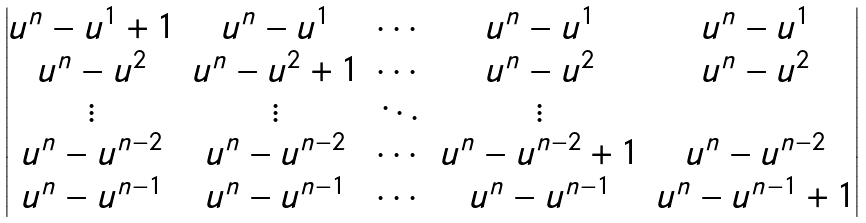Convert formula to latex. <formula><loc_0><loc_0><loc_500><loc_500>\begin{vmatrix} u ^ { n } - u ^ { 1 } + 1 & u ^ { n } - u ^ { 1 } & \cdots & u ^ { n } - u ^ { 1 } & u ^ { n } - u ^ { 1 } \\ u ^ { n } - u ^ { 2 } & u ^ { n } - u ^ { 2 } + 1 & \cdots & u ^ { n } - u ^ { 2 } & u ^ { n } - u ^ { 2 } \\ \vdots & \vdots & \ddots & \vdots \\ u ^ { n } - u ^ { n - 2 } & u ^ { n } - u ^ { n - 2 } & \cdots & u ^ { n } - u ^ { n - 2 } + 1 & u ^ { n } - u ^ { n - 2 } \\ u ^ { n } - u ^ { n - 1 } & u ^ { n } - u ^ { n - 1 } & \cdots & u ^ { n } - u ^ { n - 1 } & u ^ { n } - u ^ { n - 1 } + 1 \end{vmatrix}</formula> 